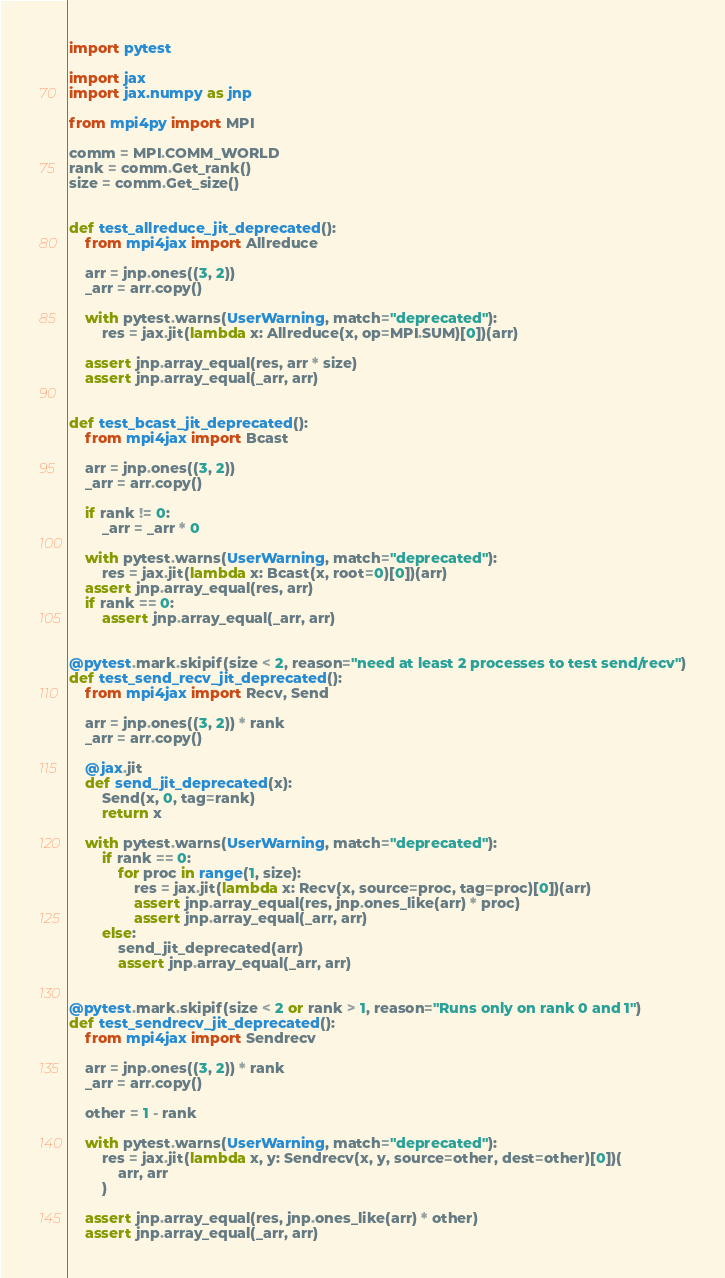Convert code to text. <code><loc_0><loc_0><loc_500><loc_500><_Python_>import pytest

import jax
import jax.numpy as jnp

from mpi4py import MPI

comm = MPI.COMM_WORLD
rank = comm.Get_rank()
size = comm.Get_size()


def test_allreduce_jit_deprecated():
    from mpi4jax import Allreduce

    arr = jnp.ones((3, 2))
    _arr = arr.copy()

    with pytest.warns(UserWarning, match="deprecated"):
        res = jax.jit(lambda x: Allreduce(x, op=MPI.SUM)[0])(arr)

    assert jnp.array_equal(res, arr * size)
    assert jnp.array_equal(_arr, arr)


def test_bcast_jit_deprecated():
    from mpi4jax import Bcast

    arr = jnp.ones((3, 2))
    _arr = arr.copy()

    if rank != 0:
        _arr = _arr * 0

    with pytest.warns(UserWarning, match="deprecated"):
        res = jax.jit(lambda x: Bcast(x, root=0)[0])(arr)
    assert jnp.array_equal(res, arr)
    if rank == 0:
        assert jnp.array_equal(_arr, arr)


@pytest.mark.skipif(size < 2, reason="need at least 2 processes to test send/recv")
def test_send_recv_jit_deprecated():
    from mpi4jax import Recv, Send

    arr = jnp.ones((3, 2)) * rank
    _arr = arr.copy()

    @jax.jit
    def send_jit_deprecated(x):
        Send(x, 0, tag=rank)
        return x

    with pytest.warns(UserWarning, match="deprecated"):
        if rank == 0:
            for proc in range(1, size):
                res = jax.jit(lambda x: Recv(x, source=proc, tag=proc)[0])(arr)
                assert jnp.array_equal(res, jnp.ones_like(arr) * proc)
                assert jnp.array_equal(_arr, arr)
        else:
            send_jit_deprecated(arr)
            assert jnp.array_equal(_arr, arr)


@pytest.mark.skipif(size < 2 or rank > 1, reason="Runs only on rank 0 and 1")
def test_sendrecv_jit_deprecated():
    from mpi4jax import Sendrecv

    arr = jnp.ones((3, 2)) * rank
    _arr = arr.copy()

    other = 1 - rank

    with pytest.warns(UserWarning, match="deprecated"):
        res = jax.jit(lambda x, y: Sendrecv(x, y, source=other, dest=other)[0])(
            arr, arr
        )

    assert jnp.array_equal(res, jnp.ones_like(arr) * other)
    assert jnp.array_equal(_arr, arr)
</code> 